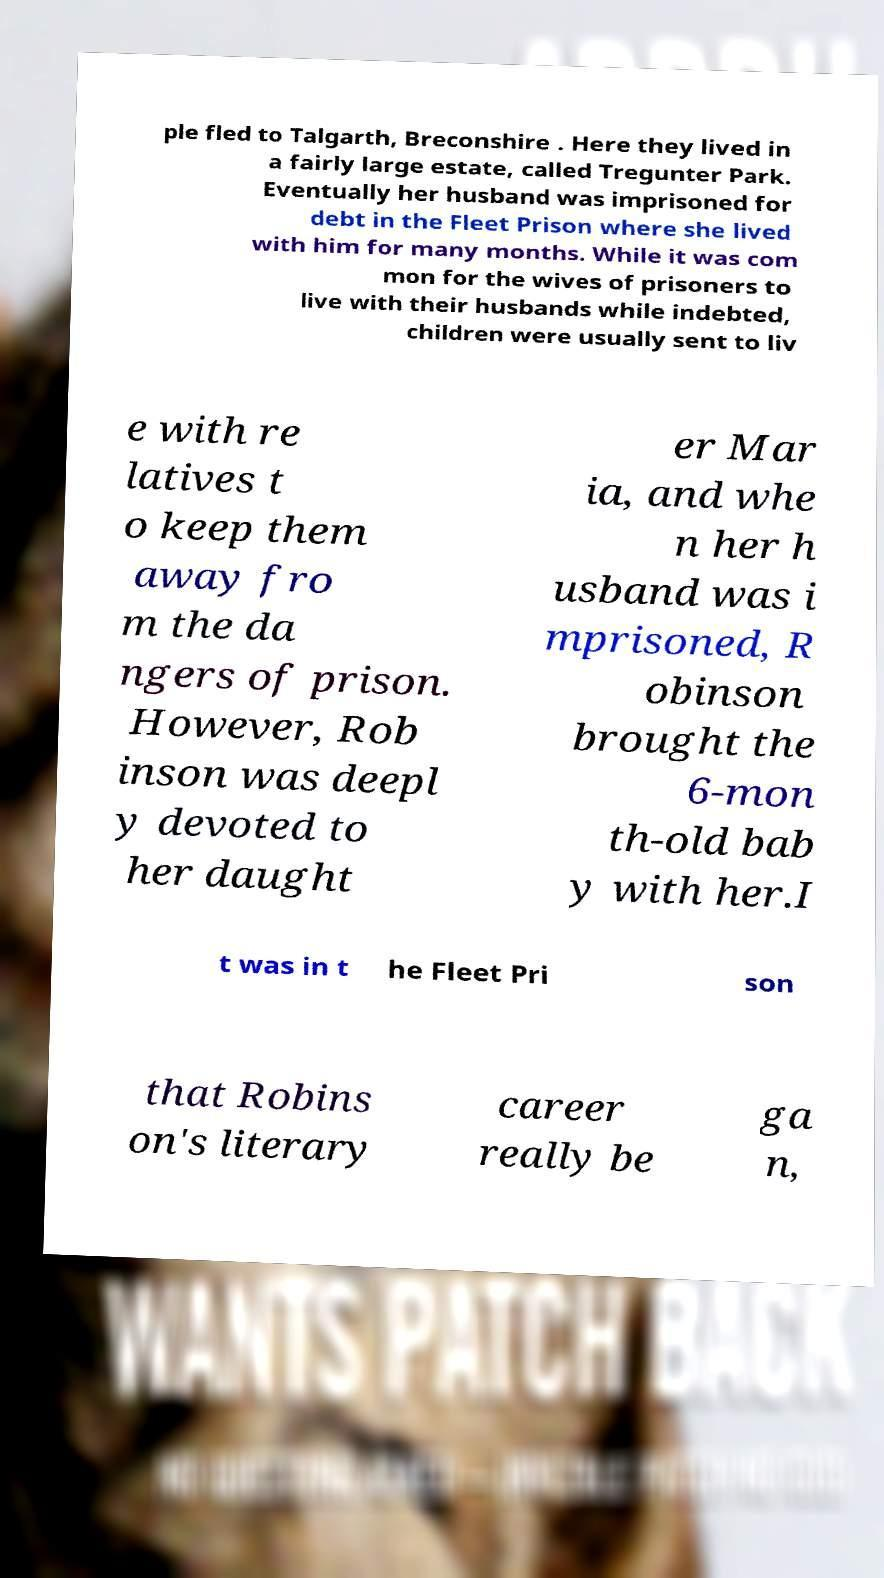Can you read and provide the text displayed in the image?This photo seems to have some interesting text. Can you extract and type it out for me? ple fled to Talgarth, Breconshire . Here they lived in a fairly large estate, called Tregunter Park. Eventually her husband was imprisoned for debt in the Fleet Prison where she lived with him for many months. While it was com mon for the wives of prisoners to live with their husbands while indebted, children were usually sent to liv e with re latives t o keep them away fro m the da ngers of prison. However, Rob inson was deepl y devoted to her daught er Mar ia, and whe n her h usband was i mprisoned, R obinson brought the 6-mon th-old bab y with her.I t was in t he Fleet Pri son that Robins on's literary career really be ga n, 